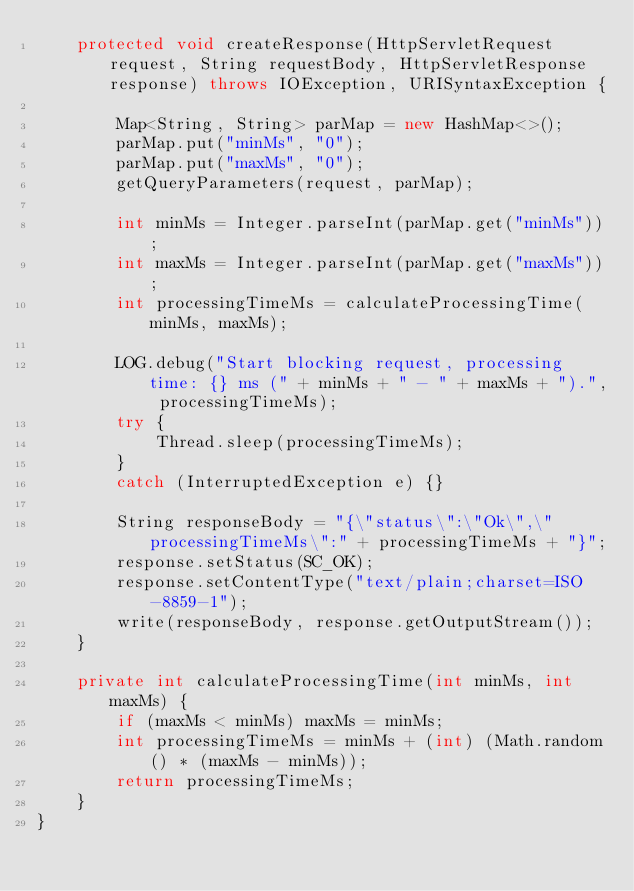Convert code to text. <code><loc_0><loc_0><loc_500><loc_500><_Java_>    protected void createResponse(HttpServletRequest request, String requestBody, HttpServletResponse response) throws IOException, URISyntaxException {

        Map<String, String> parMap = new HashMap<>();
        parMap.put("minMs", "0");
        parMap.put("maxMs", "0");
        getQueryParameters(request, parMap);

        int minMs = Integer.parseInt(parMap.get("minMs"));
        int maxMs = Integer.parseInt(parMap.get("maxMs"));
        int processingTimeMs = calculateProcessingTime(minMs, maxMs);

        LOG.debug("Start blocking request, processing time: {} ms (" + minMs + " - " + maxMs + ").", processingTimeMs);
        try {
            Thread.sleep(processingTimeMs);
        }
        catch (InterruptedException e) {}

        String responseBody = "{\"status\":\"Ok\",\"processingTimeMs\":" + processingTimeMs + "}";
        response.setStatus(SC_OK);
        response.setContentType("text/plain;charset=ISO-8859-1");
        write(responseBody, response.getOutputStream());
    }

    private int calculateProcessingTime(int minMs, int maxMs) {
        if (maxMs < minMs) maxMs = minMs;
        int processingTimeMs = minMs + (int) (Math.random() * (maxMs - minMs));
        return processingTimeMs;
    }
}</code> 